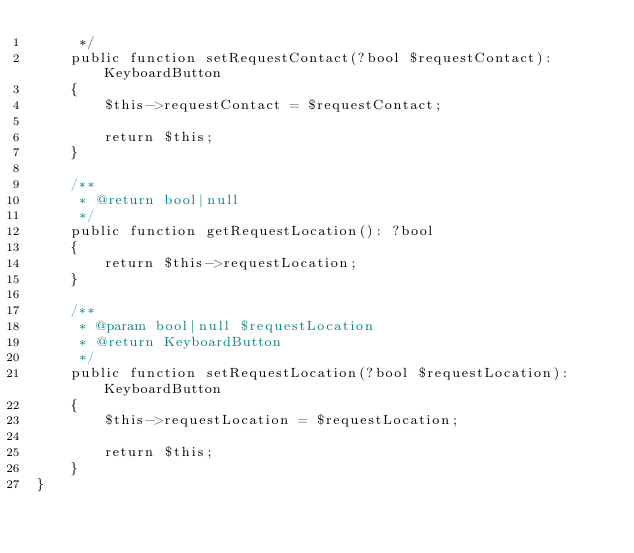Convert code to text. <code><loc_0><loc_0><loc_500><loc_500><_PHP_>     */
    public function setRequestContact(?bool $requestContact): KeyboardButton
    {
        $this->requestContact = $requestContact;

        return $this;
    }

    /**
     * @return bool|null
     */
    public function getRequestLocation(): ?bool
    {
        return $this->requestLocation;
    }

    /**
     * @param bool|null $requestLocation
     * @return KeyboardButton
     */
    public function setRequestLocation(?bool $requestLocation): KeyboardButton
    {
        $this->requestLocation = $requestLocation;

        return $this;
    }
}
</code> 